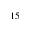Convert formula to latex. <formula><loc_0><loc_0><loc_500><loc_500>^ { 1 5 }</formula> 